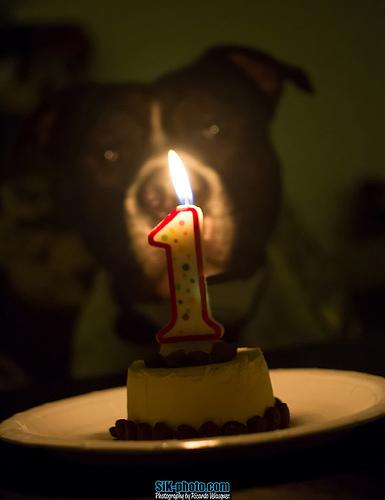Explain the interaction between the most prominent subjects in the image. A black and white dog with a white muzzle is curiously observing the bright flame of a lit red birthday candle on a cupcake. Write a sentence capturing the central focus of this image. The image focuses on a black and white dog gazing at a first birthday cupcake with a red candle atop a white plate. Mention the most significant objects in the image. A dog, a cupcake, a red number one candle, and a white plate are the main objects in the image. Imagine you are the birthday cupcake; describe how the scene looks from your perspective. From my perspective as a cupcake, I see a black and white dog intently staring at my lit red number one birthday candle. Enumerate the three main elements in the image and their colors. The image features a black and white dog, a white-frosted cupcake, and a red number one candle. Summarize the scene captured in the image. A black and white dog is looking at a birthday cupcake with a red number one candle on a white plate. Narrate the situation in the image from the perspective of the dog. As a curious dog, I am intently watching the bright flame of a red number one candle atop a delicious cupcake. Describe the image using simple and concise language. A dog watches a red number one candle burning on a birthday cupcake placed on a white plate. Write a sentence mentioning the birthday element in the image. The image captures the celebration of a first birthday, with a red number one candle adorning a white-frosted cupcake. Provide a detailed description of the cake in the image. The cake is a small, white-frosted cupcake adorned with chocolate chips and berries, with a red number one birthday candle on top. 